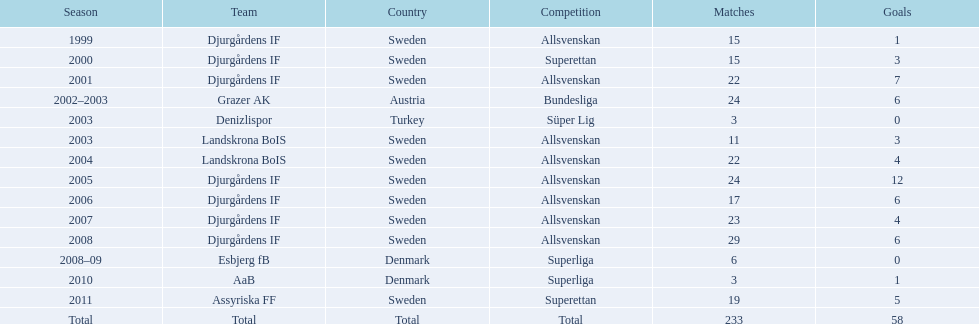How many teams had above 20 matches in the season? 6. 